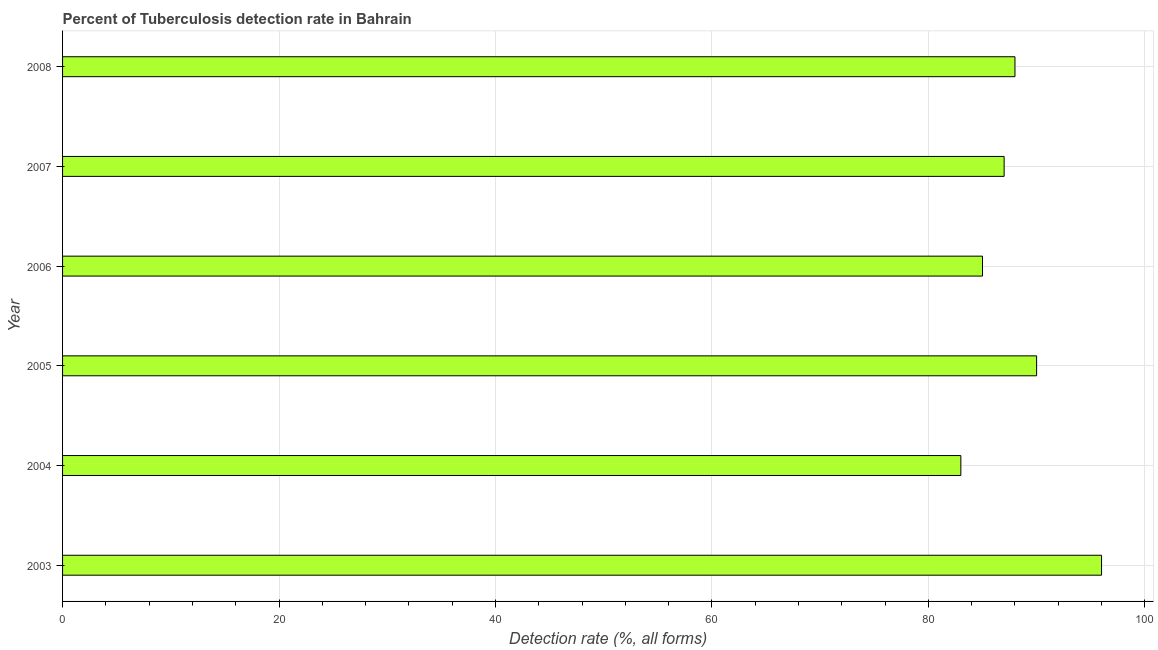Does the graph contain any zero values?
Your answer should be very brief. No. Does the graph contain grids?
Provide a succinct answer. Yes. What is the title of the graph?
Ensure brevity in your answer.  Percent of Tuberculosis detection rate in Bahrain. What is the label or title of the X-axis?
Offer a very short reply. Detection rate (%, all forms). What is the label or title of the Y-axis?
Give a very brief answer. Year. What is the detection rate of tuberculosis in 2008?
Your answer should be very brief. 88. Across all years, what is the maximum detection rate of tuberculosis?
Provide a short and direct response. 96. In which year was the detection rate of tuberculosis maximum?
Your answer should be compact. 2003. In which year was the detection rate of tuberculosis minimum?
Provide a short and direct response. 2004. What is the sum of the detection rate of tuberculosis?
Offer a very short reply. 529. What is the median detection rate of tuberculosis?
Provide a succinct answer. 87.5. Do a majority of the years between 2006 and 2005 (inclusive) have detection rate of tuberculosis greater than 96 %?
Keep it short and to the point. No. What is the ratio of the detection rate of tuberculosis in 2004 to that in 2007?
Provide a succinct answer. 0.95. Is the difference between the detection rate of tuberculosis in 2004 and 2006 greater than the difference between any two years?
Keep it short and to the point. No. What is the difference between the highest and the second highest detection rate of tuberculosis?
Your response must be concise. 6. Is the sum of the detection rate of tuberculosis in 2003 and 2004 greater than the maximum detection rate of tuberculosis across all years?
Your answer should be very brief. Yes. How many years are there in the graph?
Offer a very short reply. 6. What is the Detection rate (%, all forms) in 2003?
Make the answer very short. 96. What is the Detection rate (%, all forms) of 2006?
Ensure brevity in your answer.  85. What is the Detection rate (%, all forms) of 2007?
Keep it short and to the point. 87. What is the difference between the Detection rate (%, all forms) in 2003 and 2006?
Provide a short and direct response. 11. What is the difference between the Detection rate (%, all forms) in 2003 and 2008?
Give a very brief answer. 8. What is the difference between the Detection rate (%, all forms) in 2004 and 2005?
Make the answer very short. -7. What is the difference between the Detection rate (%, all forms) in 2004 and 2007?
Make the answer very short. -4. What is the difference between the Detection rate (%, all forms) in 2004 and 2008?
Make the answer very short. -5. What is the difference between the Detection rate (%, all forms) in 2005 and 2006?
Make the answer very short. 5. What is the difference between the Detection rate (%, all forms) in 2006 and 2007?
Give a very brief answer. -2. What is the difference between the Detection rate (%, all forms) in 2006 and 2008?
Offer a very short reply. -3. What is the ratio of the Detection rate (%, all forms) in 2003 to that in 2004?
Make the answer very short. 1.16. What is the ratio of the Detection rate (%, all forms) in 2003 to that in 2005?
Your answer should be very brief. 1.07. What is the ratio of the Detection rate (%, all forms) in 2003 to that in 2006?
Provide a short and direct response. 1.13. What is the ratio of the Detection rate (%, all forms) in 2003 to that in 2007?
Your answer should be compact. 1.1. What is the ratio of the Detection rate (%, all forms) in 2003 to that in 2008?
Offer a very short reply. 1.09. What is the ratio of the Detection rate (%, all forms) in 2004 to that in 2005?
Offer a very short reply. 0.92. What is the ratio of the Detection rate (%, all forms) in 2004 to that in 2007?
Provide a short and direct response. 0.95. What is the ratio of the Detection rate (%, all forms) in 2004 to that in 2008?
Ensure brevity in your answer.  0.94. What is the ratio of the Detection rate (%, all forms) in 2005 to that in 2006?
Make the answer very short. 1.06. What is the ratio of the Detection rate (%, all forms) in 2005 to that in 2007?
Provide a short and direct response. 1.03. What is the ratio of the Detection rate (%, all forms) in 2005 to that in 2008?
Offer a very short reply. 1.02. What is the ratio of the Detection rate (%, all forms) in 2006 to that in 2007?
Ensure brevity in your answer.  0.98. What is the ratio of the Detection rate (%, all forms) in 2006 to that in 2008?
Offer a very short reply. 0.97. 